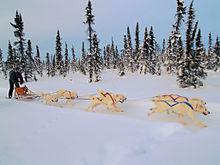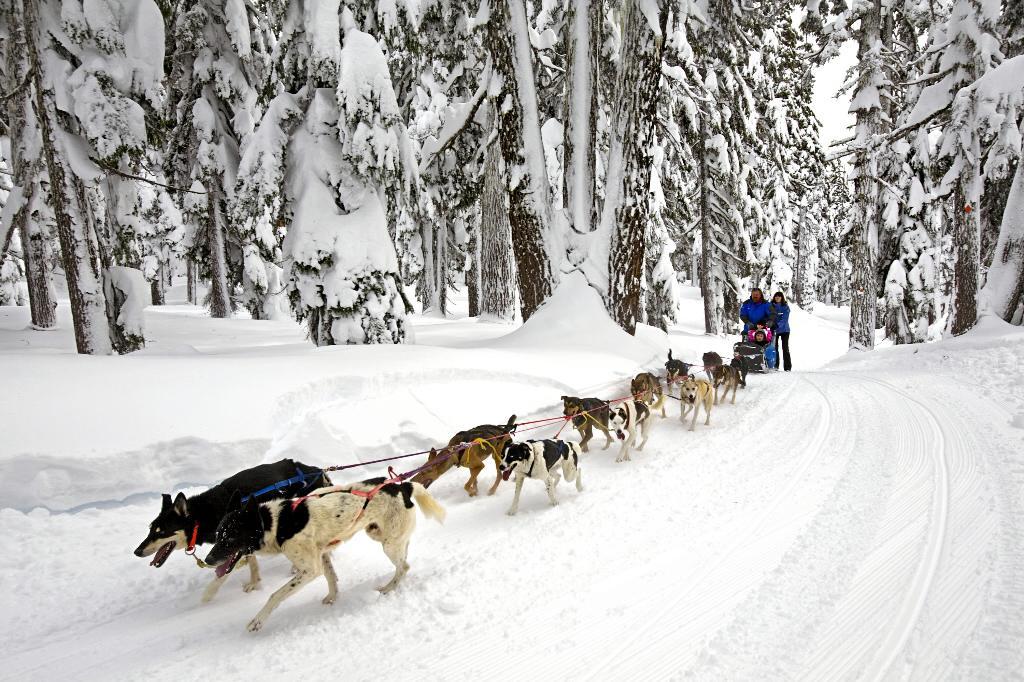The first image is the image on the left, the second image is the image on the right. For the images displayed, is the sentence "There are no trees behind the dogs in at least one of the images." factually correct? Answer yes or no. No. 